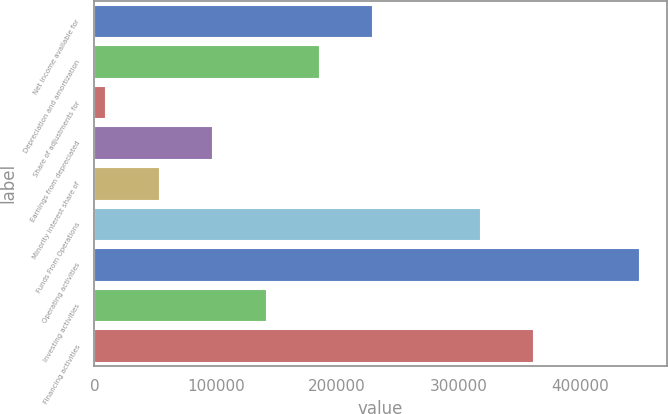Convert chart to OTSL. <chart><loc_0><loc_0><loc_500><loc_500><bar_chart><fcel>Net income available for<fcel>Depreciation and amortization<fcel>Share of adjustments for<fcel>Earnings from depreciated<fcel>Minority interest share of<fcel>Funds From Operations<fcel>Operating activities<fcel>Investing activities<fcel>Financing activities<nl><fcel>229117<fcel>185114<fcel>9104<fcel>97109.2<fcel>53106.6<fcel>317360<fcel>449130<fcel>141112<fcel>361363<nl></chart> 